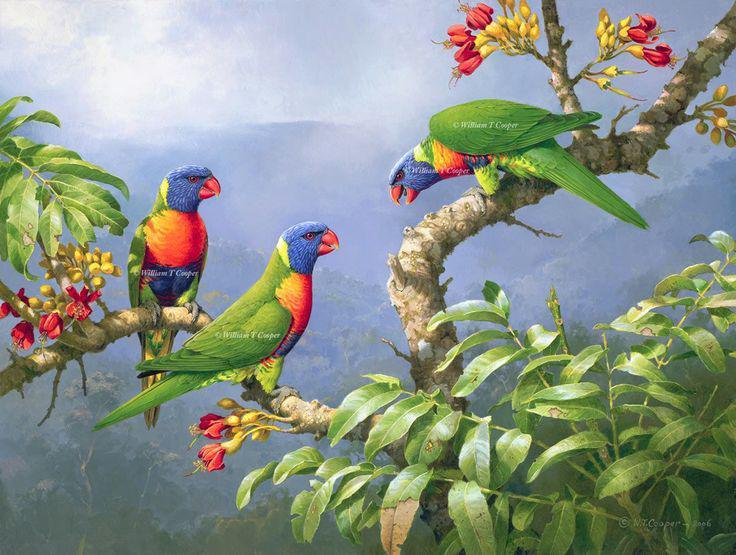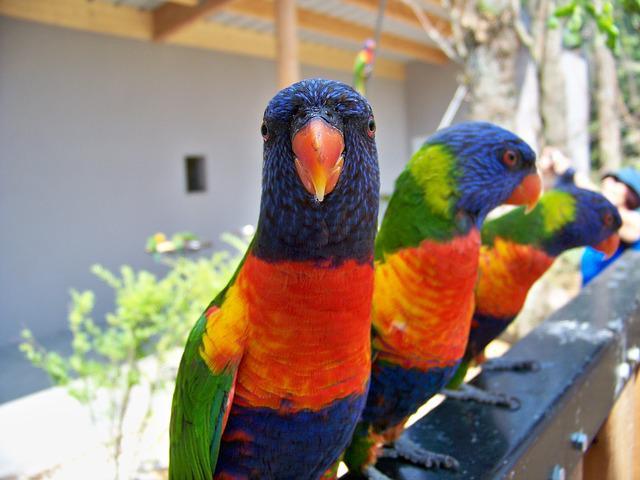The first image is the image on the left, the second image is the image on the right. Assess this claim about the two images: "Three birds perch on a branch in the image on the left.". Correct or not? Answer yes or no. Yes. The first image is the image on the left, the second image is the image on the right. For the images shown, is this caption "The left image shows exactly three multicolored parrots." true? Answer yes or no. Yes. 